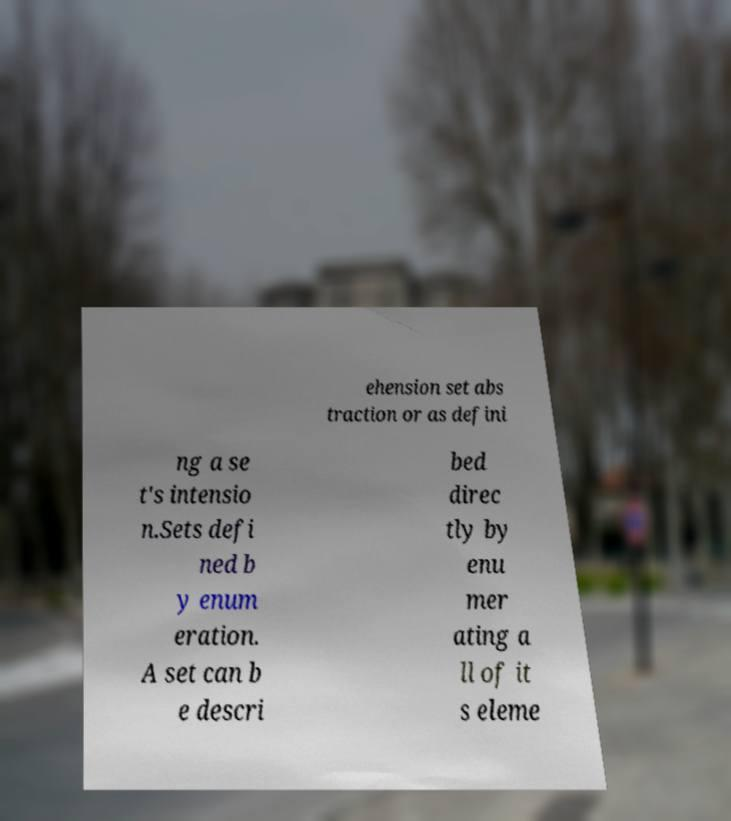Please read and relay the text visible in this image. What does it say? ehension set abs traction or as defini ng a se t's intensio n.Sets defi ned b y enum eration. A set can b e descri bed direc tly by enu mer ating a ll of it s eleme 